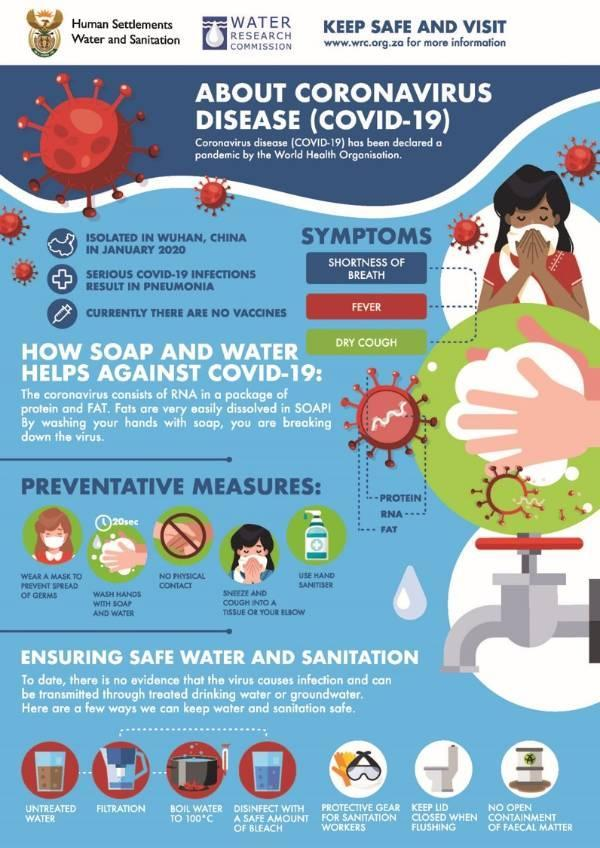How many ways to ensure safe water and sanitation?
Answer the question with a short phrase. 7 How many preventive measures are in this infographic? 5 Which are the two components of RNA of coronavirus? Protein, Fat 